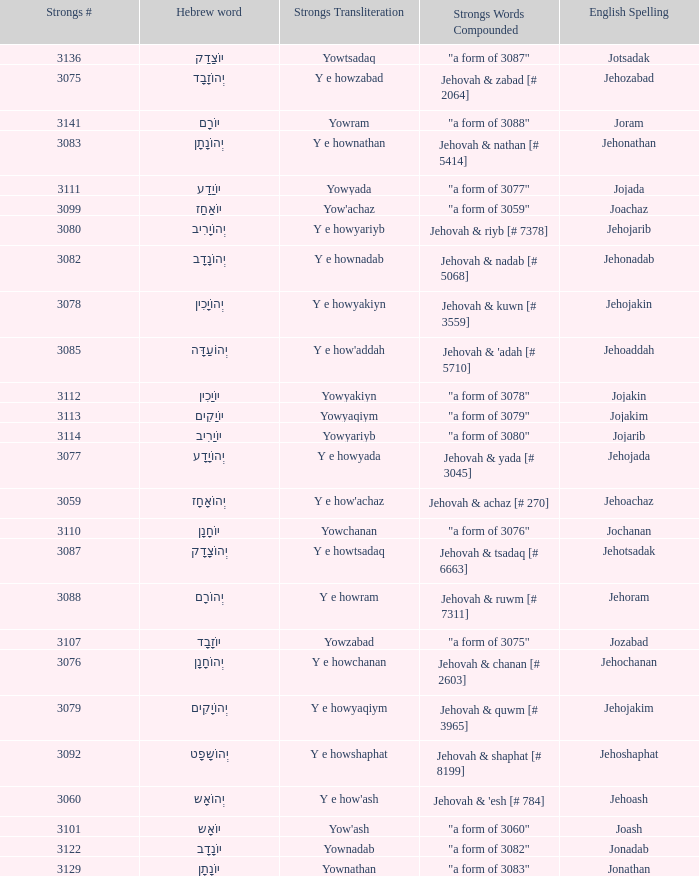What is the strongs # of the english spelling word jehojakin? 3078.0. 